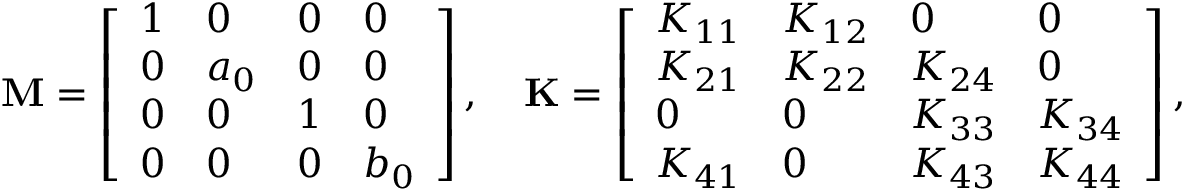Convert formula to latex. <formula><loc_0><loc_0><loc_500><loc_500>M = \left [ \begin{array} { l l l l } { 1 } & { 0 } & { 0 } & { 0 } \\ { 0 } & { a _ { 0 } } & { 0 } & { 0 } \\ { 0 } & { 0 } & { 1 } & { 0 } \\ { 0 } & { 0 } & { 0 } & { b _ { 0 } } \end{array} \right ] , \quad K = \left [ \begin{array} { l l l l } { K _ { 1 1 } } & { K _ { 1 2 } } & { 0 } & { 0 } \\ { K _ { 2 1 } } & { K _ { 2 2 } } & { K _ { 2 4 } } & { 0 } \\ { 0 } & { 0 } & { K _ { 3 3 } } & { K _ { 3 4 } } \\ { K _ { 4 1 } } & { 0 } & { K _ { 4 3 } } & { K _ { 4 4 } } \end{array} \right ] ,</formula> 